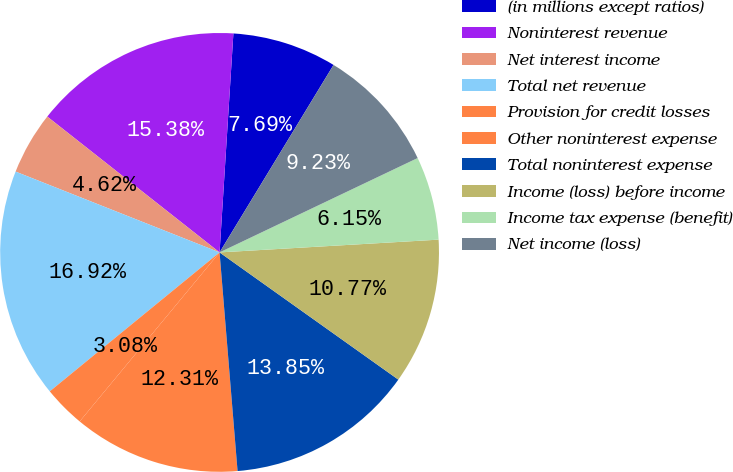Convert chart to OTSL. <chart><loc_0><loc_0><loc_500><loc_500><pie_chart><fcel>(in millions except ratios)<fcel>Noninterest revenue<fcel>Net interest income<fcel>Total net revenue<fcel>Provision for credit losses<fcel>Other noninterest expense<fcel>Total noninterest expense<fcel>Income (loss) before income<fcel>Income tax expense (benefit)<fcel>Net income (loss)<nl><fcel>7.69%<fcel>15.38%<fcel>4.62%<fcel>16.92%<fcel>3.08%<fcel>12.31%<fcel>13.85%<fcel>10.77%<fcel>6.15%<fcel>9.23%<nl></chart> 